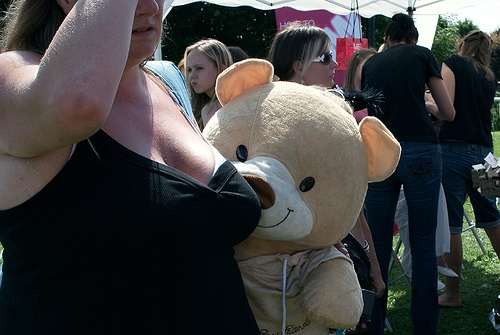Describe the objects in this image and their specific colors. I can see people in black, gray, maroon, and lightgray tones, teddy bear in black, gray, and darkgray tones, people in black, gray, and darkblue tones, people in black, gray, and darkblue tones, and people in black, gray, and darkgray tones in this image. 